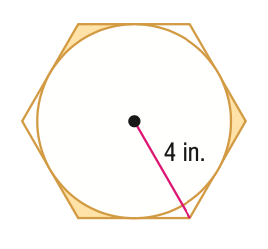Answer the mathemtical geometry problem and directly provide the correct option letter.
Question: Find the area of the shaded region formed by the circle and regular polygon. Round to the nearest tenth.
Choices: A: 0.6 B: 1.3 C: 1.9 D: 3.9 C 